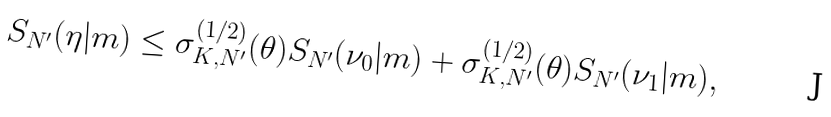<formula> <loc_0><loc_0><loc_500><loc_500>S _ { N ^ { \prime } } ( \eta | m ) \leq \sigma ^ { ( 1 / 2 ) } _ { K , N ^ { \prime } } ( \theta ) S _ { N ^ { \prime } } ( \nu _ { 0 } | m ) + \sigma ^ { ( 1 / 2 ) } _ { K , N ^ { \prime } } ( \theta ) S _ { N ^ { \prime } } ( \nu _ { 1 } | m ) ,</formula> 